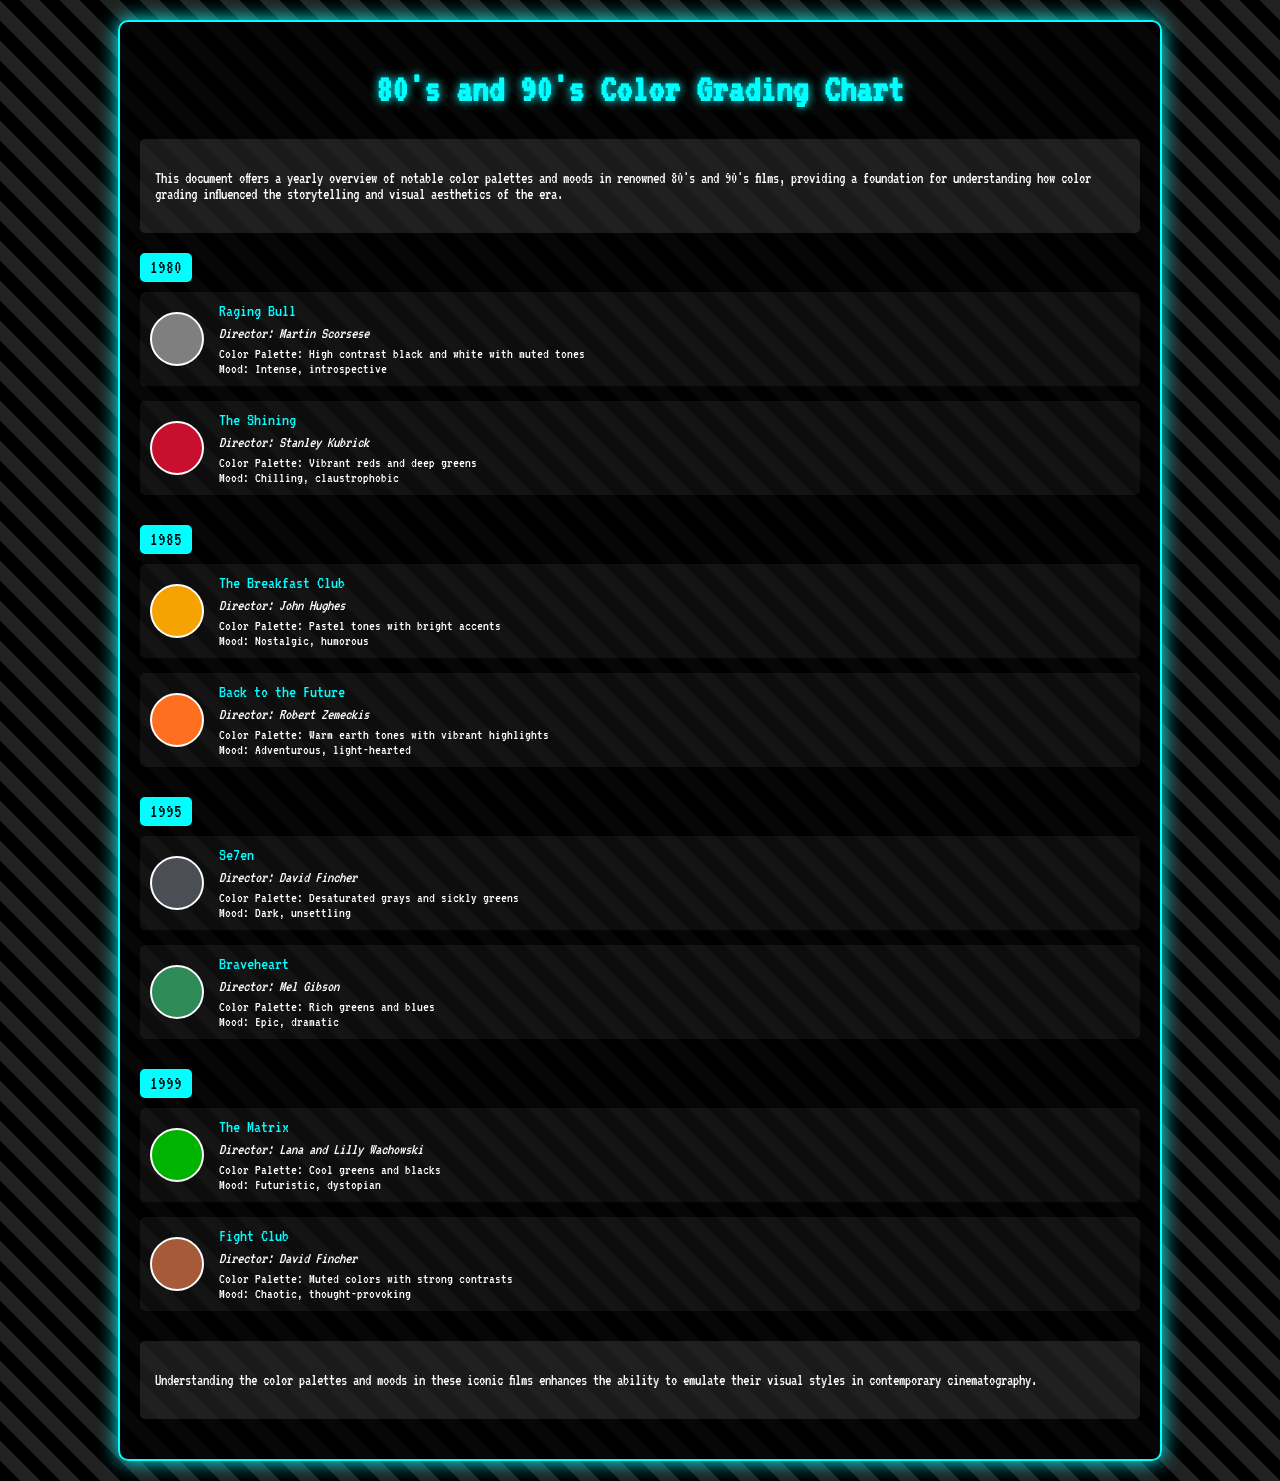What film was directed by Martin Scorsese in 1980? The document lists "Raging Bull" directed by Martin Scorsese as a film from 1980.
Answer: Raging Bull What color swatch is associated with "The Shining"? The color swatch for "The Shining" is described as vibrant reds and deep greens, represented by the swatch's color.
Answer: Vibrant reds and deep greens What is the mood of "The Breakfast Club"? The document states that the mood of "The Breakfast Club" is nostalgic and humorous.
Answer: Nostalgic, humorous In what year was "Fight Club" released? "Fight Club" is listed under the year 1999 in the document.
Answer: 1999 Which two directors are mentioned for the film "The Matrix"? Lana and Lilly Wachowski are the directors of "The Matrix" as per the document.
Answer: Lana and Lilly Wachowski What type of color palette is used in "Se7en"? The palette for "Se7en" is described as desaturated grays and sickly greens.
Answer: Desaturated grays and sickly greens How many films are referenced for the year 1995? The document mentions two films for the year 1995.
Answer: Two What kind of mood is associated with "Braveheart"? The mood of "Braveheart" is described as epic and dramatic in the document.
Answer: Epic, dramatic What overarching theme is explored in this color grading chart? The theme focuses on notable color palettes and moods in renowned 80's and 90's films.
Answer: Notable color palettes and moods in renowned 80's and 90's films 